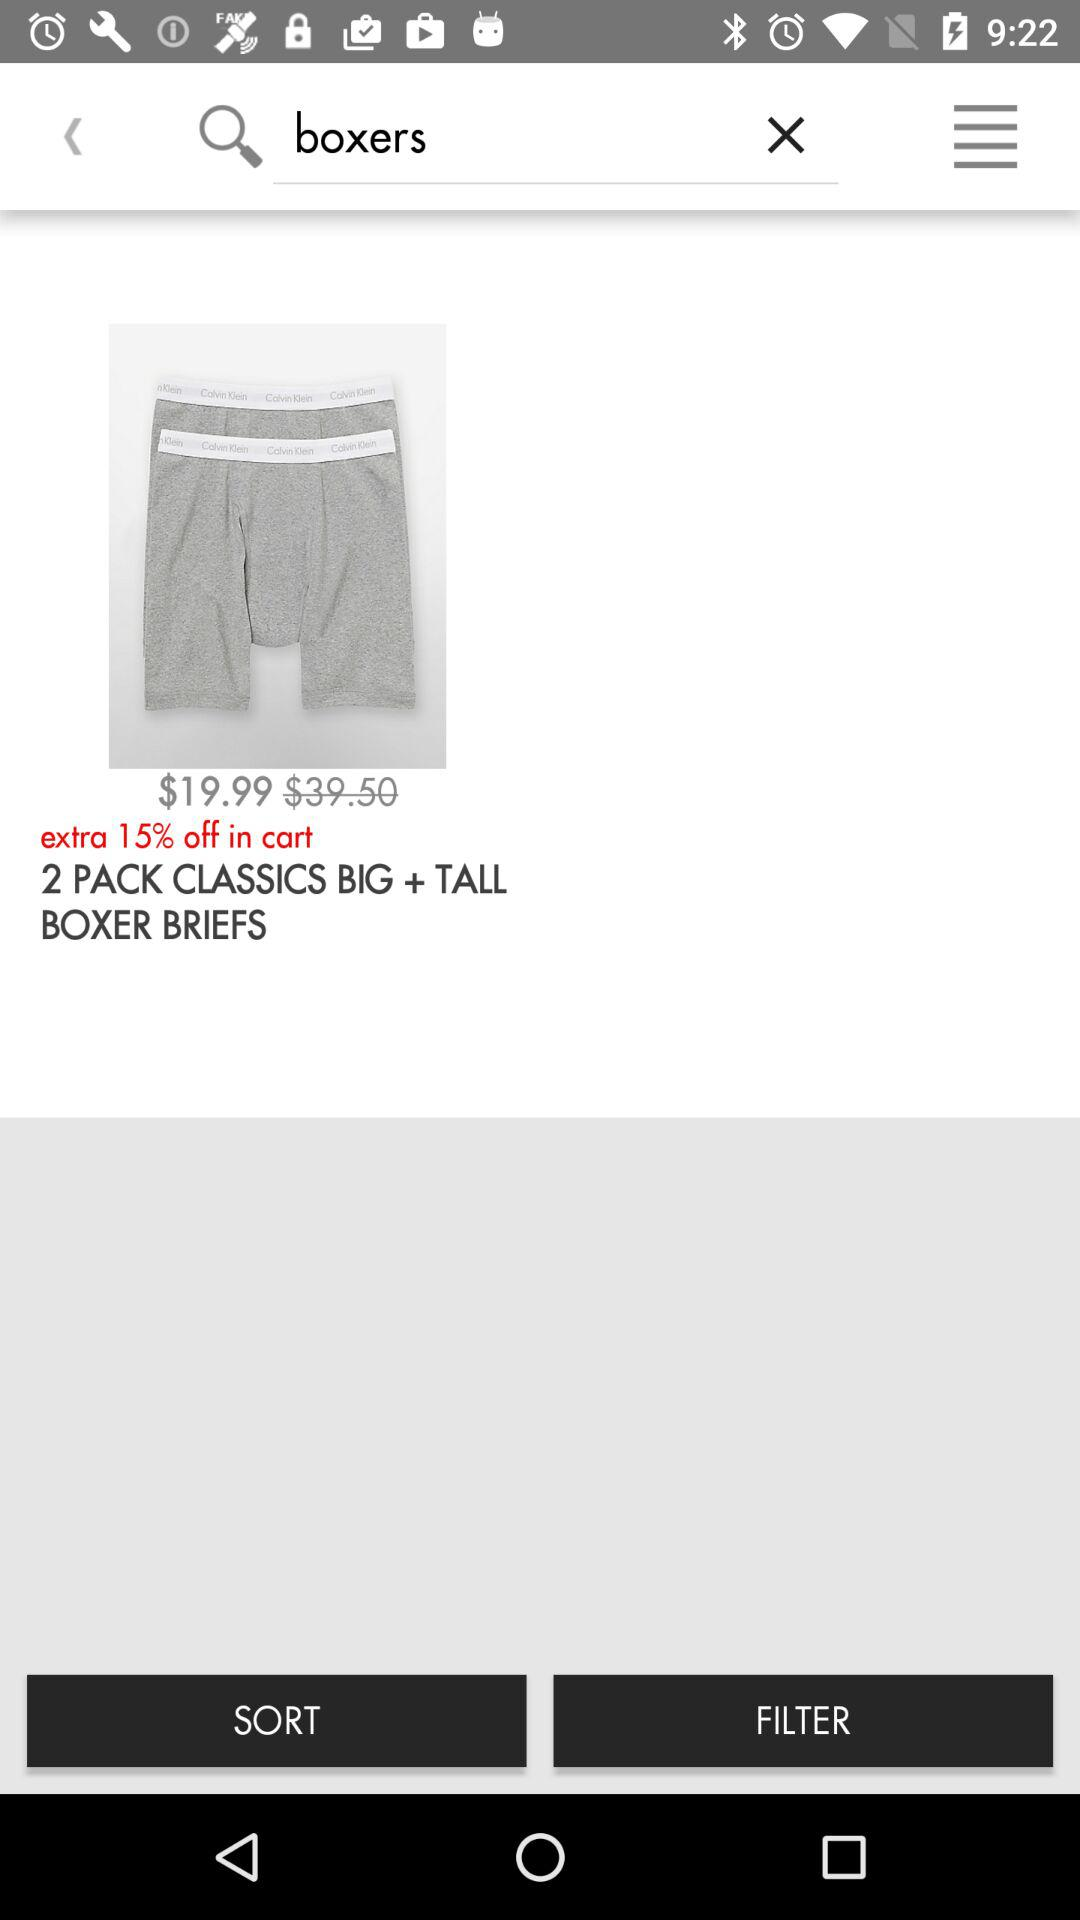How many boxers are in the pack?
Answer the question using a single word or phrase. 2 